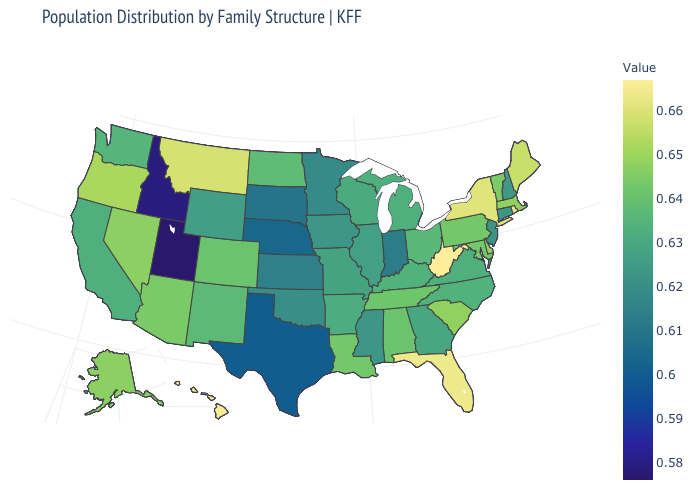Does Georgia have a lower value than Massachusetts?
Write a very short answer. Yes. Does Alabama have the lowest value in the South?
Concise answer only. No. Does Utah have the lowest value in the USA?
Concise answer only. Yes. Is the legend a continuous bar?
Write a very short answer. Yes. Among the states that border Montana , does Idaho have the highest value?
Write a very short answer. No. Among the states that border Maine , which have the highest value?
Be succinct. New Hampshire. 